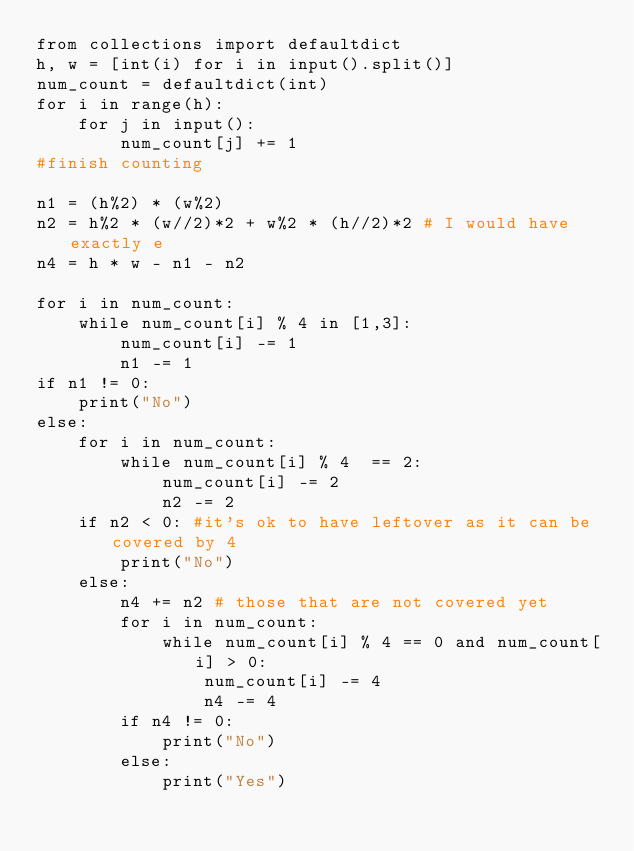Convert code to text. <code><loc_0><loc_0><loc_500><loc_500><_Python_>from collections import defaultdict
h, w = [int(i) for i in input().split()]
num_count = defaultdict(int)
for i in range(h):
    for j in input():
        num_count[j] += 1
#finish counting

n1 = (h%2) * (w%2)
n2 = h%2 * (w//2)*2 + w%2 * (h//2)*2 # I would have exactly e
n4 = h * w - n1 - n2

for i in num_count:
    while num_count[i] % 4 in [1,3]:
        num_count[i] -= 1
        n1 -= 1
if n1 != 0:
    print("No")
else:
    for i in num_count:
        while num_count[i] % 4  == 2:
            num_count[i] -= 2
            n2 -= 2
    if n2 < 0: #it's ok to have leftover as it can be covered by 4
        print("No")
    else:
        n4 += n2 # those that are not covered yet
        for i in num_count:
            while num_count[i] % 4 == 0 and num_count[i] > 0:
                num_count[i] -= 4
                n4 -= 4
        if n4 != 0:
            print("No")
        else:
            print("Yes")
</code> 